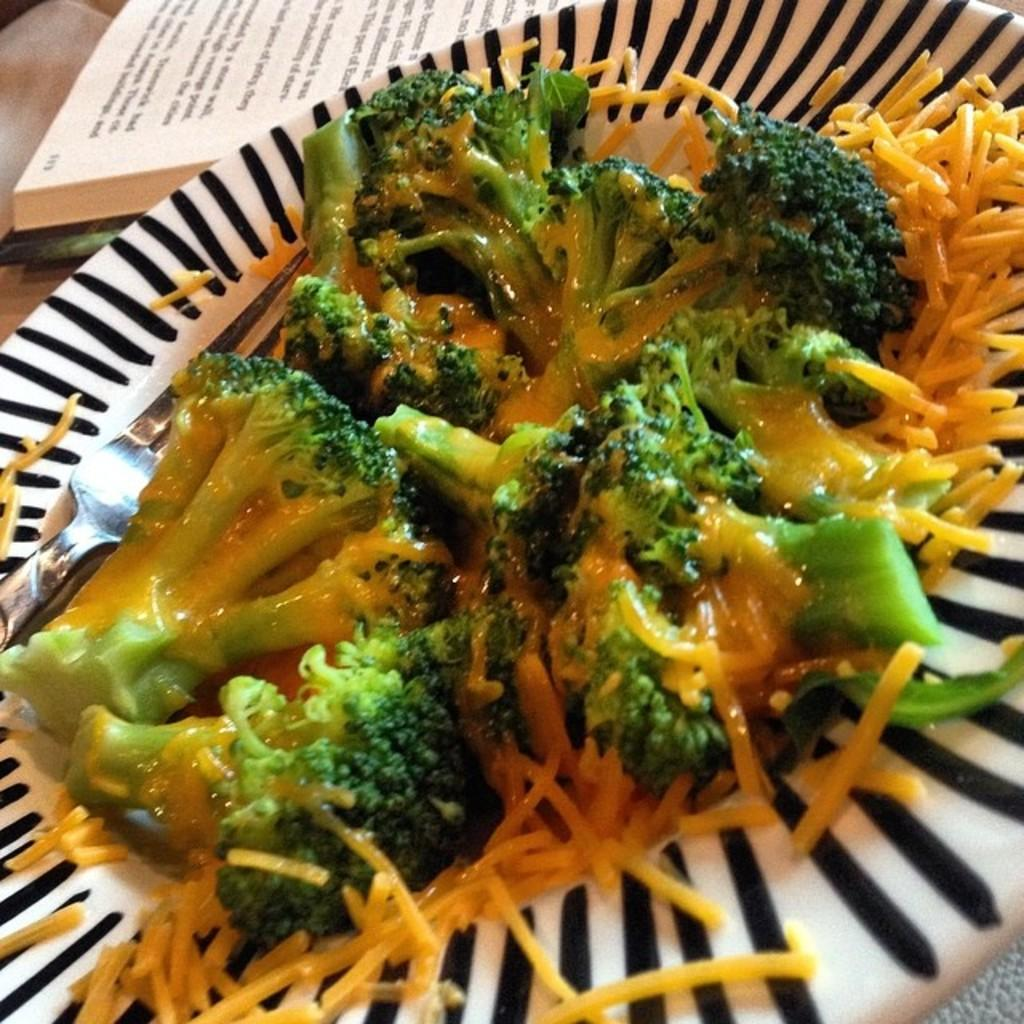What is on the plate in the image? There is food on a plate in the image. Can you identify any specific type of food in the image? Yes, there is broccoli in the image. Where is the fork located in the image? The fork is on the left side of the image. What else can be seen on the table in the image? There is a book placed on a table in the image. What type of texture can be seen on the dogs in the image? There are no dogs present in the image, so it is not possible to determine their texture. 